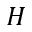Convert formula to latex. <formula><loc_0><loc_0><loc_500><loc_500>H</formula> 